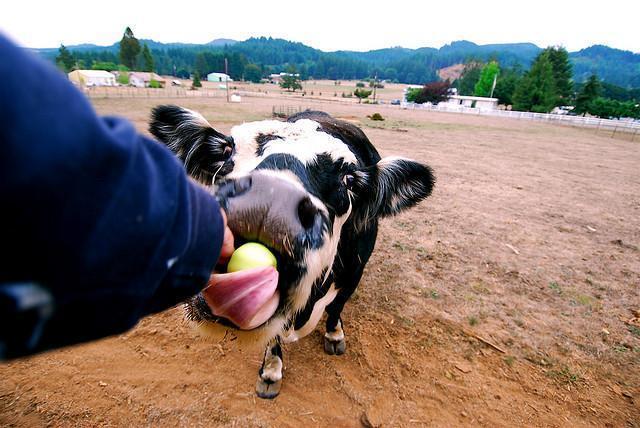Is the given caption "The person is facing away from the cow." fitting for the image?
Answer yes or no. No. Does the image validate the caption "The cow is at the back of the person."?
Answer yes or no. No. Verify the accuracy of this image caption: "The cow is facing the person.".
Answer yes or no. Yes. Does the caption "The person is at the back of the cow." correctly depict the image?
Answer yes or no. No. 